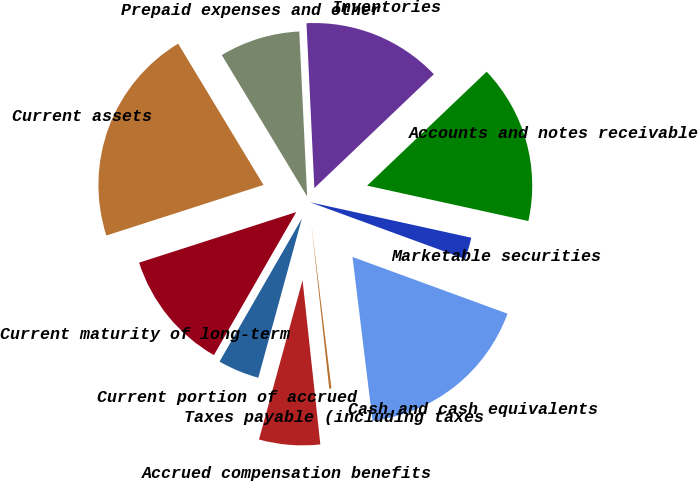Convert chart. <chart><loc_0><loc_0><loc_500><loc_500><pie_chart><fcel>Cash and cash equivalents<fcel>Marketable securities<fcel>Accounts and notes receivable<fcel>Inventories<fcel>Prepaid expenses and other<fcel>Current assets<fcel>Current maturity of long-term<fcel>Current portion of accrued<fcel>Accrued compensation benefits<fcel>Taxes payable (including taxes<nl><fcel>17.48%<fcel>2.14%<fcel>15.56%<fcel>13.64%<fcel>7.89%<fcel>21.31%<fcel>11.73%<fcel>4.06%<fcel>5.97%<fcel>0.22%<nl></chart> 